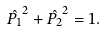<formula> <loc_0><loc_0><loc_500><loc_500>\hat { P _ { 1 } } ^ { 2 } + \hat { P _ { 2 } } ^ { 2 } = 1 .</formula> 